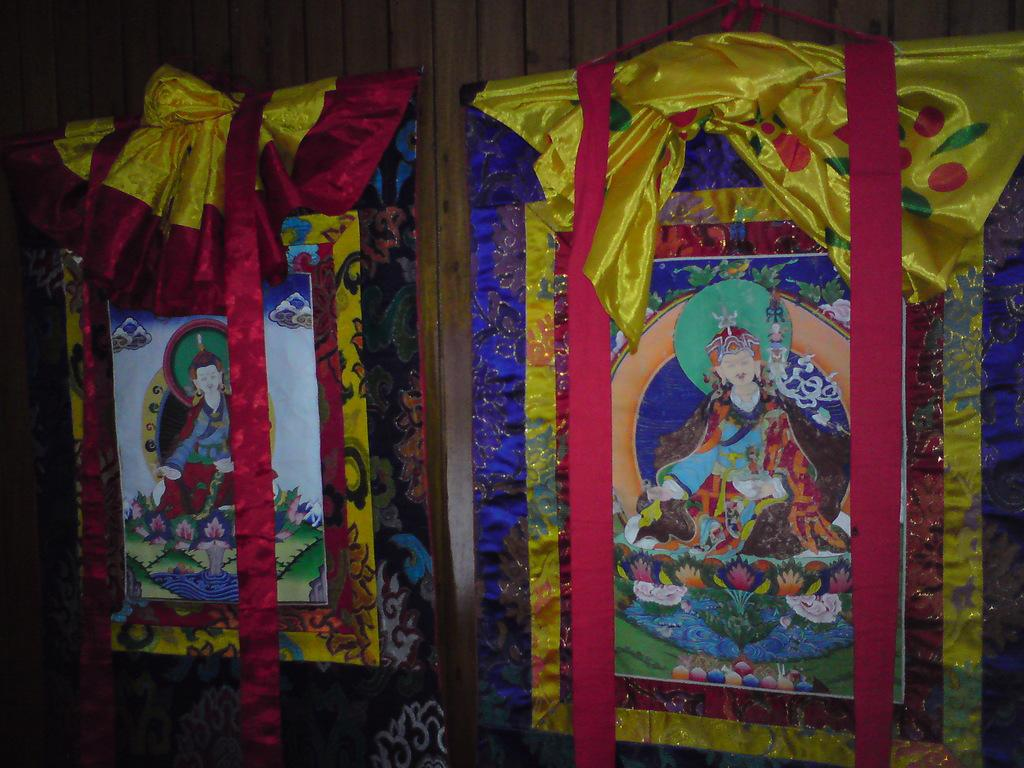What type of wall is visible in the image? There is a wooden wall in the image. What can be seen hanging on the wooden wall? There are frames on the wooden wall. What type of muscle is visible in the image? There is no muscle visible in the image; it features a wooden wall with frames. 